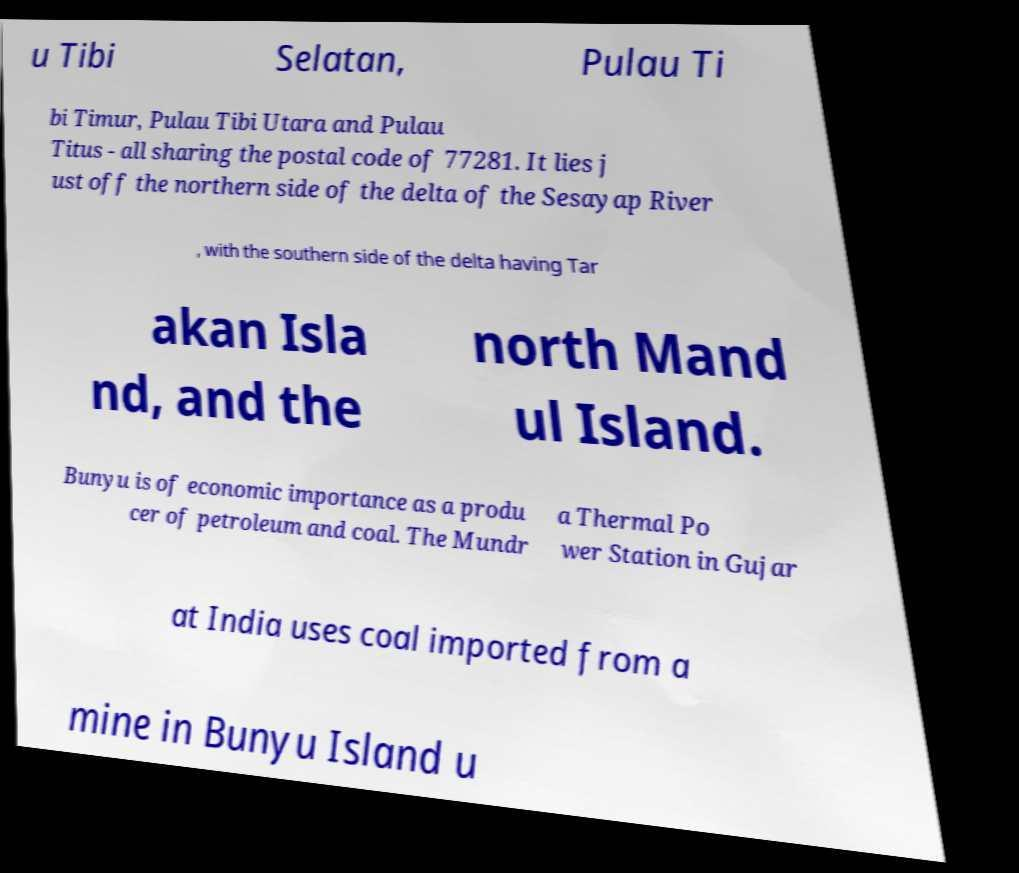Can you read and provide the text displayed in the image?This photo seems to have some interesting text. Can you extract and type it out for me? u Tibi Selatan, Pulau Ti bi Timur, Pulau Tibi Utara and Pulau Titus - all sharing the postal code of 77281. It lies j ust off the northern side of the delta of the Sesayap River , with the southern side of the delta having Tar akan Isla nd, and the north Mand ul Island. Bunyu is of economic importance as a produ cer of petroleum and coal. The Mundr a Thermal Po wer Station in Gujar at India uses coal imported from a mine in Bunyu Island u 